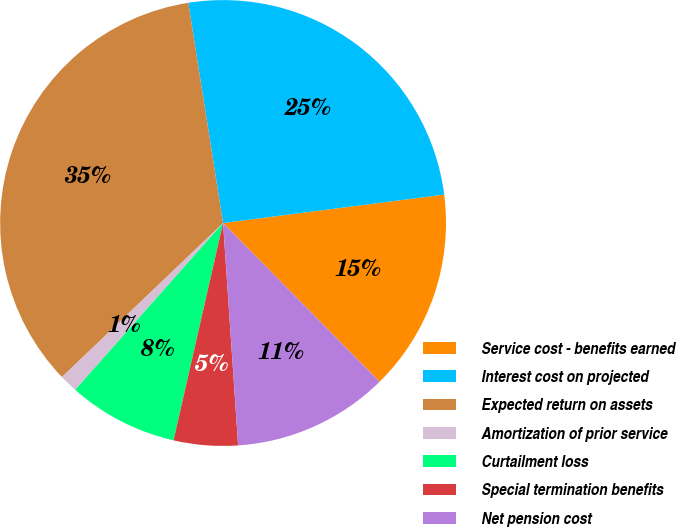Convert chart to OTSL. <chart><loc_0><loc_0><loc_500><loc_500><pie_chart><fcel>Service cost - benefits earned<fcel>Interest cost on projected<fcel>Expected return on assets<fcel>Amortization of prior service<fcel>Curtailment loss<fcel>Special termination benefits<fcel>Net pension cost<nl><fcel>14.65%<fcel>25.46%<fcel>34.65%<fcel>1.31%<fcel>7.98%<fcel>4.64%<fcel>11.31%<nl></chart> 